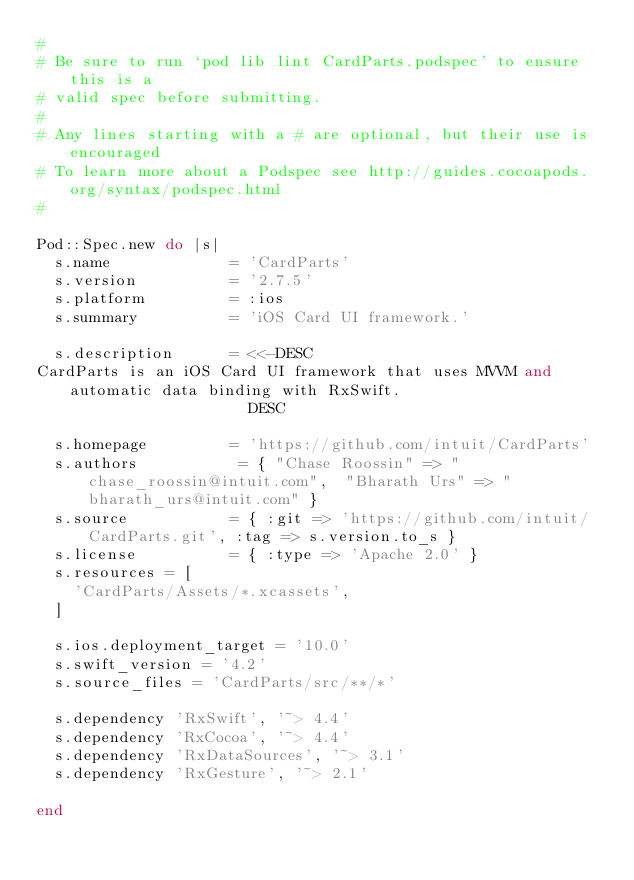<code> <loc_0><loc_0><loc_500><loc_500><_Ruby_>#
# Be sure to run `pod lib lint CardParts.podspec' to ensure this is a
# valid spec before submitting.
#
# Any lines starting with a # are optional, but their use is encouraged
# To learn more about a Podspec see http://guides.cocoapods.org/syntax/podspec.html
#

Pod::Spec.new do |s|
  s.name             = 'CardParts'
  s.version          = '2.7.5'
  s.platform         = :ios
  s.summary          = 'iOS Card UI framework.'

  s.description      = <<-DESC
CardParts is an iOS Card UI framework that uses MVVM and automatic data binding with RxSwift.
                       DESC

  s.homepage         = 'https://github.com/intuit/CardParts'
  s.authors           = { "Chase Roossin" => "chase_roossin@intuit.com",  "Bharath Urs" => "bharath_urs@intuit.com" }
  s.source           = { :git => 'https://github.com/intuit/CardParts.git', :tag => s.version.to_s }
  s.license          = { :type => 'Apache 2.0' }
  s.resources = [
    'CardParts/Assets/*.xcassets',
  ]

  s.ios.deployment_target = '10.0'
  s.swift_version = '4.2'
  s.source_files = 'CardParts/src/**/*'

  s.dependency 'RxSwift', '~> 4.4'
  s.dependency 'RxCocoa', '~> 4.4'
  s.dependency 'RxDataSources', '~> 3.1'
  s.dependency 'RxGesture', '~> 2.1'

end
</code> 